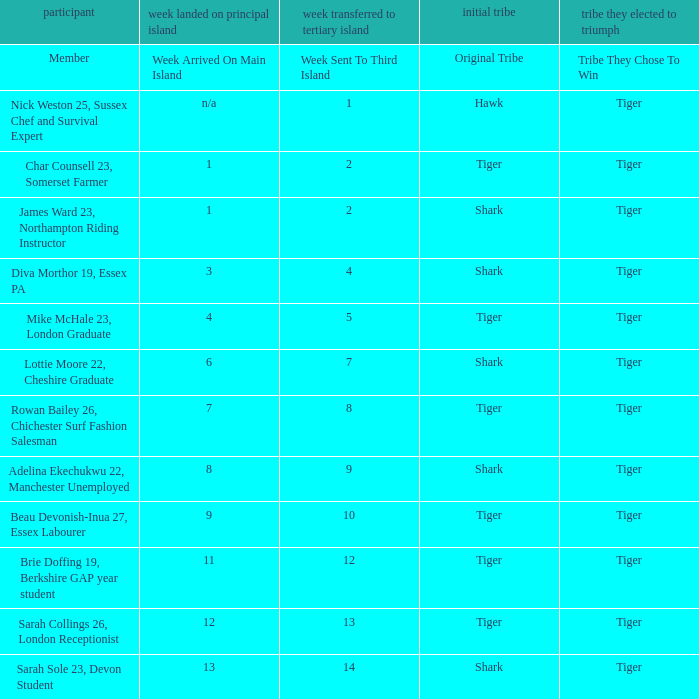How many members arrived on the main island in week 4? 1.0. 